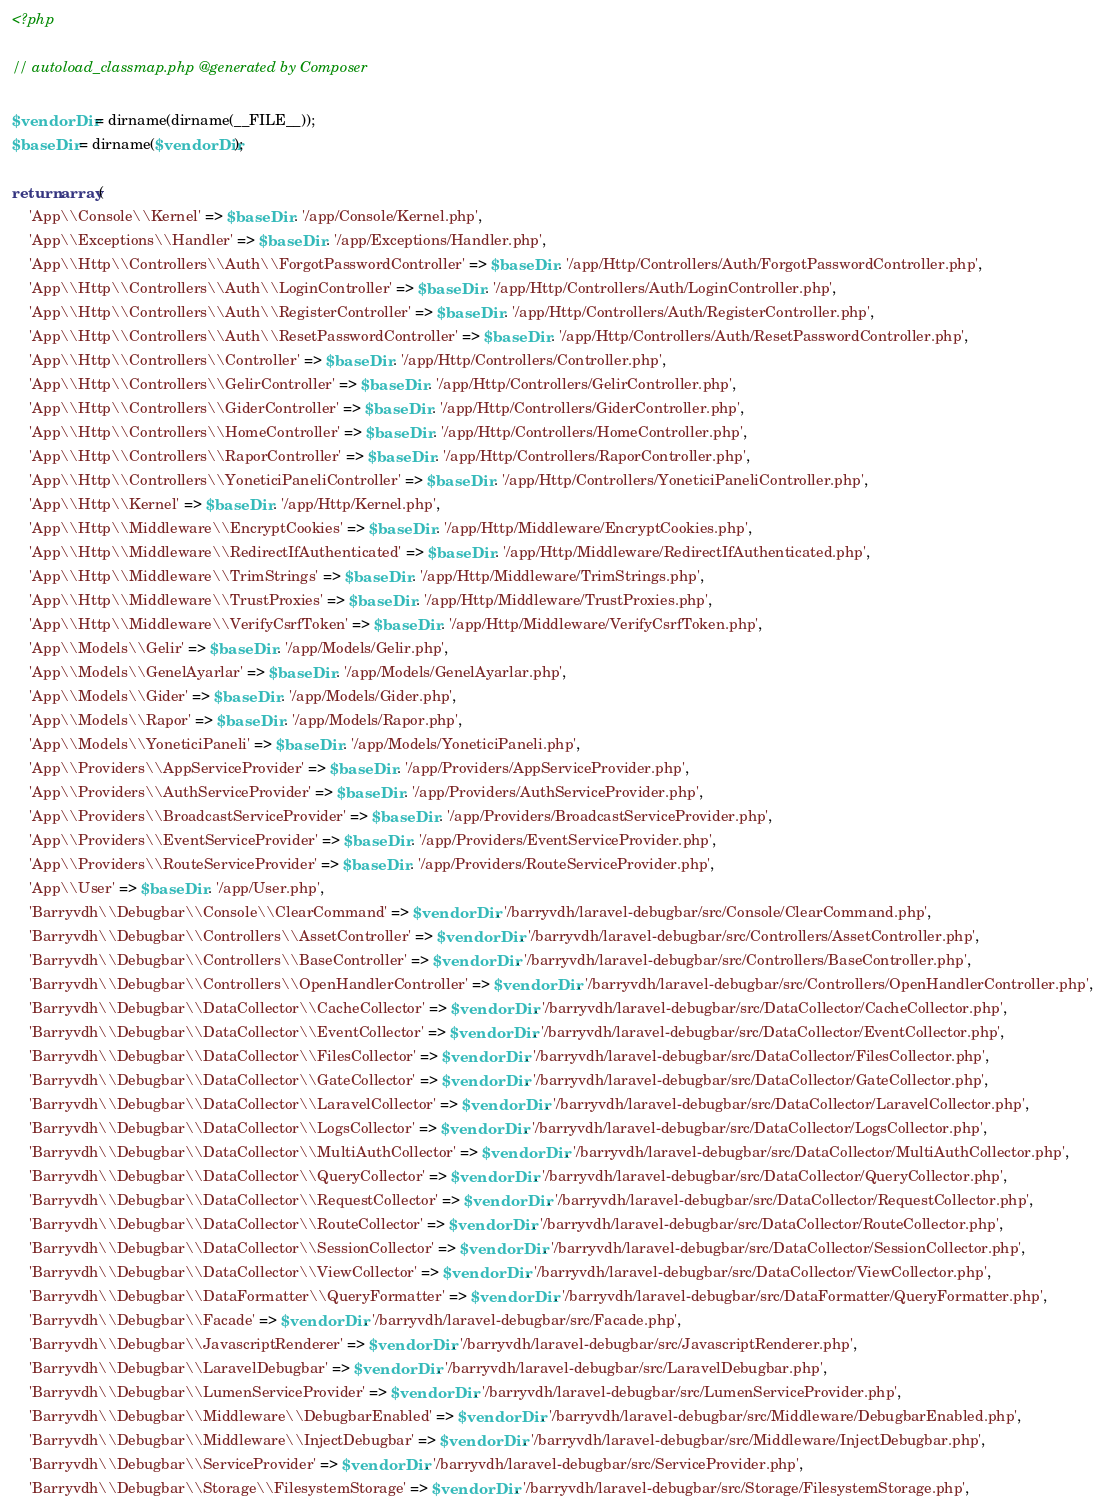Convert code to text. <code><loc_0><loc_0><loc_500><loc_500><_PHP_><?php

// autoload_classmap.php @generated by Composer

$vendorDir = dirname(dirname(__FILE__));
$baseDir = dirname($vendorDir);

return array(
    'App\\Console\\Kernel' => $baseDir . '/app/Console/Kernel.php',
    'App\\Exceptions\\Handler' => $baseDir . '/app/Exceptions/Handler.php',
    'App\\Http\\Controllers\\Auth\\ForgotPasswordController' => $baseDir . '/app/Http/Controllers/Auth/ForgotPasswordController.php',
    'App\\Http\\Controllers\\Auth\\LoginController' => $baseDir . '/app/Http/Controllers/Auth/LoginController.php',
    'App\\Http\\Controllers\\Auth\\RegisterController' => $baseDir . '/app/Http/Controllers/Auth/RegisterController.php',
    'App\\Http\\Controllers\\Auth\\ResetPasswordController' => $baseDir . '/app/Http/Controllers/Auth/ResetPasswordController.php',
    'App\\Http\\Controllers\\Controller' => $baseDir . '/app/Http/Controllers/Controller.php',
    'App\\Http\\Controllers\\GelirController' => $baseDir . '/app/Http/Controllers/GelirController.php',
    'App\\Http\\Controllers\\GiderController' => $baseDir . '/app/Http/Controllers/GiderController.php',
    'App\\Http\\Controllers\\HomeController' => $baseDir . '/app/Http/Controllers/HomeController.php',
    'App\\Http\\Controllers\\RaporController' => $baseDir . '/app/Http/Controllers/RaporController.php',
    'App\\Http\\Controllers\\YoneticiPaneliController' => $baseDir . '/app/Http/Controllers/YoneticiPaneliController.php',
    'App\\Http\\Kernel' => $baseDir . '/app/Http/Kernel.php',
    'App\\Http\\Middleware\\EncryptCookies' => $baseDir . '/app/Http/Middleware/EncryptCookies.php',
    'App\\Http\\Middleware\\RedirectIfAuthenticated' => $baseDir . '/app/Http/Middleware/RedirectIfAuthenticated.php',
    'App\\Http\\Middleware\\TrimStrings' => $baseDir . '/app/Http/Middleware/TrimStrings.php',
    'App\\Http\\Middleware\\TrustProxies' => $baseDir . '/app/Http/Middleware/TrustProxies.php',
    'App\\Http\\Middleware\\VerifyCsrfToken' => $baseDir . '/app/Http/Middleware/VerifyCsrfToken.php',
    'App\\Models\\Gelir' => $baseDir . '/app/Models/Gelir.php',
    'App\\Models\\GenelAyarlar' => $baseDir . '/app/Models/GenelAyarlar.php',
    'App\\Models\\Gider' => $baseDir . '/app/Models/Gider.php',
    'App\\Models\\Rapor' => $baseDir . '/app/Models/Rapor.php',
    'App\\Models\\YoneticiPaneli' => $baseDir . '/app/Models/YoneticiPaneli.php',
    'App\\Providers\\AppServiceProvider' => $baseDir . '/app/Providers/AppServiceProvider.php',
    'App\\Providers\\AuthServiceProvider' => $baseDir . '/app/Providers/AuthServiceProvider.php',
    'App\\Providers\\BroadcastServiceProvider' => $baseDir . '/app/Providers/BroadcastServiceProvider.php',
    'App\\Providers\\EventServiceProvider' => $baseDir . '/app/Providers/EventServiceProvider.php',
    'App\\Providers\\RouteServiceProvider' => $baseDir . '/app/Providers/RouteServiceProvider.php',
    'App\\User' => $baseDir . '/app/User.php',
    'Barryvdh\\Debugbar\\Console\\ClearCommand' => $vendorDir . '/barryvdh/laravel-debugbar/src/Console/ClearCommand.php',
    'Barryvdh\\Debugbar\\Controllers\\AssetController' => $vendorDir . '/barryvdh/laravel-debugbar/src/Controllers/AssetController.php',
    'Barryvdh\\Debugbar\\Controllers\\BaseController' => $vendorDir . '/barryvdh/laravel-debugbar/src/Controllers/BaseController.php',
    'Barryvdh\\Debugbar\\Controllers\\OpenHandlerController' => $vendorDir . '/barryvdh/laravel-debugbar/src/Controllers/OpenHandlerController.php',
    'Barryvdh\\Debugbar\\DataCollector\\CacheCollector' => $vendorDir . '/barryvdh/laravel-debugbar/src/DataCollector/CacheCollector.php',
    'Barryvdh\\Debugbar\\DataCollector\\EventCollector' => $vendorDir . '/barryvdh/laravel-debugbar/src/DataCollector/EventCollector.php',
    'Barryvdh\\Debugbar\\DataCollector\\FilesCollector' => $vendorDir . '/barryvdh/laravel-debugbar/src/DataCollector/FilesCollector.php',
    'Barryvdh\\Debugbar\\DataCollector\\GateCollector' => $vendorDir . '/barryvdh/laravel-debugbar/src/DataCollector/GateCollector.php',
    'Barryvdh\\Debugbar\\DataCollector\\LaravelCollector' => $vendorDir . '/barryvdh/laravel-debugbar/src/DataCollector/LaravelCollector.php',
    'Barryvdh\\Debugbar\\DataCollector\\LogsCollector' => $vendorDir . '/barryvdh/laravel-debugbar/src/DataCollector/LogsCollector.php',
    'Barryvdh\\Debugbar\\DataCollector\\MultiAuthCollector' => $vendorDir . '/barryvdh/laravel-debugbar/src/DataCollector/MultiAuthCollector.php',
    'Barryvdh\\Debugbar\\DataCollector\\QueryCollector' => $vendorDir . '/barryvdh/laravel-debugbar/src/DataCollector/QueryCollector.php',
    'Barryvdh\\Debugbar\\DataCollector\\RequestCollector' => $vendorDir . '/barryvdh/laravel-debugbar/src/DataCollector/RequestCollector.php',
    'Barryvdh\\Debugbar\\DataCollector\\RouteCollector' => $vendorDir . '/barryvdh/laravel-debugbar/src/DataCollector/RouteCollector.php',
    'Barryvdh\\Debugbar\\DataCollector\\SessionCollector' => $vendorDir . '/barryvdh/laravel-debugbar/src/DataCollector/SessionCollector.php',
    'Barryvdh\\Debugbar\\DataCollector\\ViewCollector' => $vendorDir . '/barryvdh/laravel-debugbar/src/DataCollector/ViewCollector.php',
    'Barryvdh\\Debugbar\\DataFormatter\\QueryFormatter' => $vendorDir . '/barryvdh/laravel-debugbar/src/DataFormatter/QueryFormatter.php',
    'Barryvdh\\Debugbar\\Facade' => $vendorDir . '/barryvdh/laravel-debugbar/src/Facade.php',
    'Barryvdh\\Debugbar\\JavascriptRenderer' => $vendorDir . '/barryvdh/laravel-debugbar/src/JavascriptRenderer.php',
    'Barryvdh\\Debugbar\\LaravelDebugbar' => $vendorDir . '/barryvdh/laravel-debugbar/src/LaravelDebugbar.php',
    'Barryvdh\\Debugbar\\LumenServiceProvider' => $vendorDir . '/barryvdh/laravel-debugbar/src/LumenServiceProvider.php',
    'Barryvdh\\Debugbar\\Middleware\\DebugbarEnabled' => $vendorDir . '/barryvdh/laravel-debugbar/src/Middleware/DebugbarEnabled.php',
    'Barryvdh\\Debugbar\\Middleware\\InjectDebugbar' => $vendorDir . '/barryvdh/laravel-debugbar/src/Middleware/InjectDebugbar.php',
    'Barryvdh\\Debugbar\\ServiceProvider' => $vendorDir . '/barryvdh/laravel-debugbar/src/ServiceProvider.php',
    'Barryvdh\\Debugbar\\Storage\\FilesystemStorage' => $vendorDir . '/barryvdh/laravel-debugbar/src/Storage/FilesystemStorage.php',</code> 